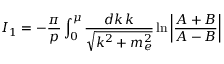Convert formula to latex. <formula><loc_0><loc_0><loc_500><loc_500>I _ { 1 } = - \frac { \pi } { p } \int _ { 0 } ^ { \mu } \frac { d k \, k } { \sqrt { k ^ { 2 } + m _ { e } ^ { 2 } } } \ln \left | \frac { A + B } { A - B } \right |</formula> 